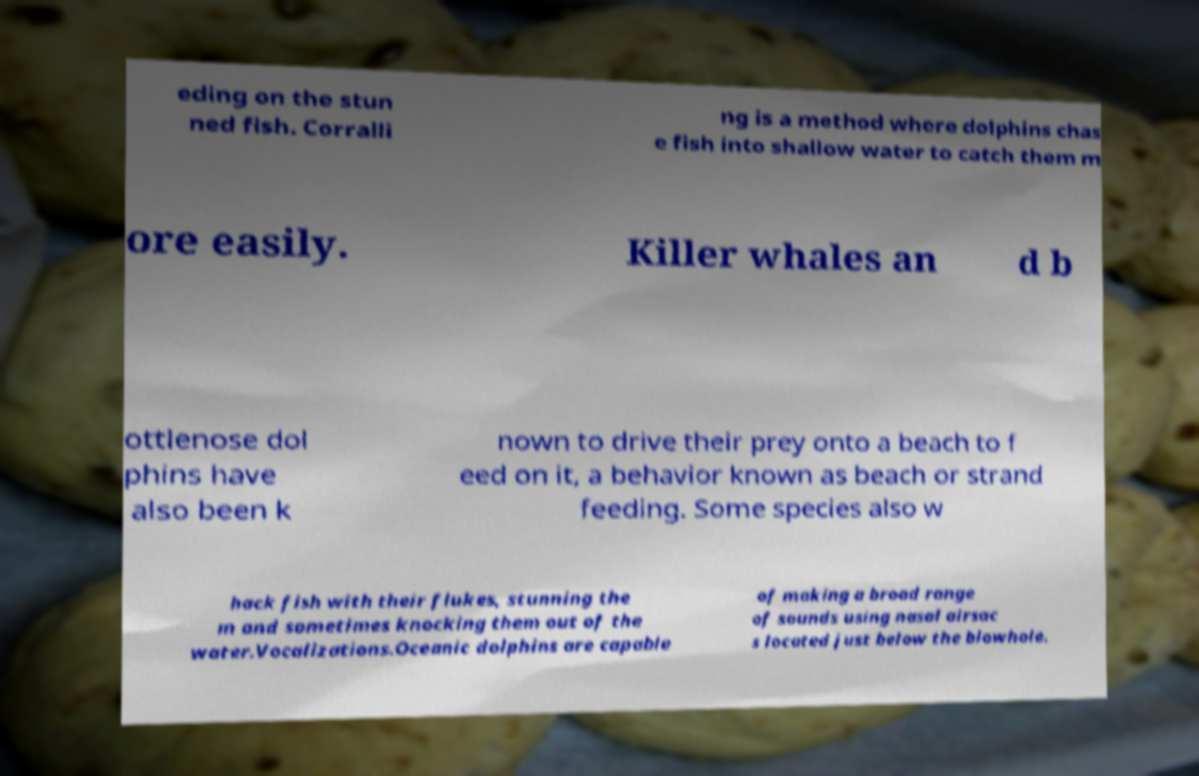I need the written content from this picture converted into text. Can you do that? eding on the stun ned fish. Corralli ng is a method where dolphins chas e fish into shallow water to catch them m ore easily. Killer whales an d b ottlenose dol phins have also been k nown to drive their prey onto a beach to f eed on it, a behavior known as beach or strand feeding. Some species also w hack fish with their flukes, stunning the m and sometimes knocking them out of the water.Vocalizations.Oceanic dolphins are capable of making a broad range of sounds using nasal airsac s located just below the blowhole. 